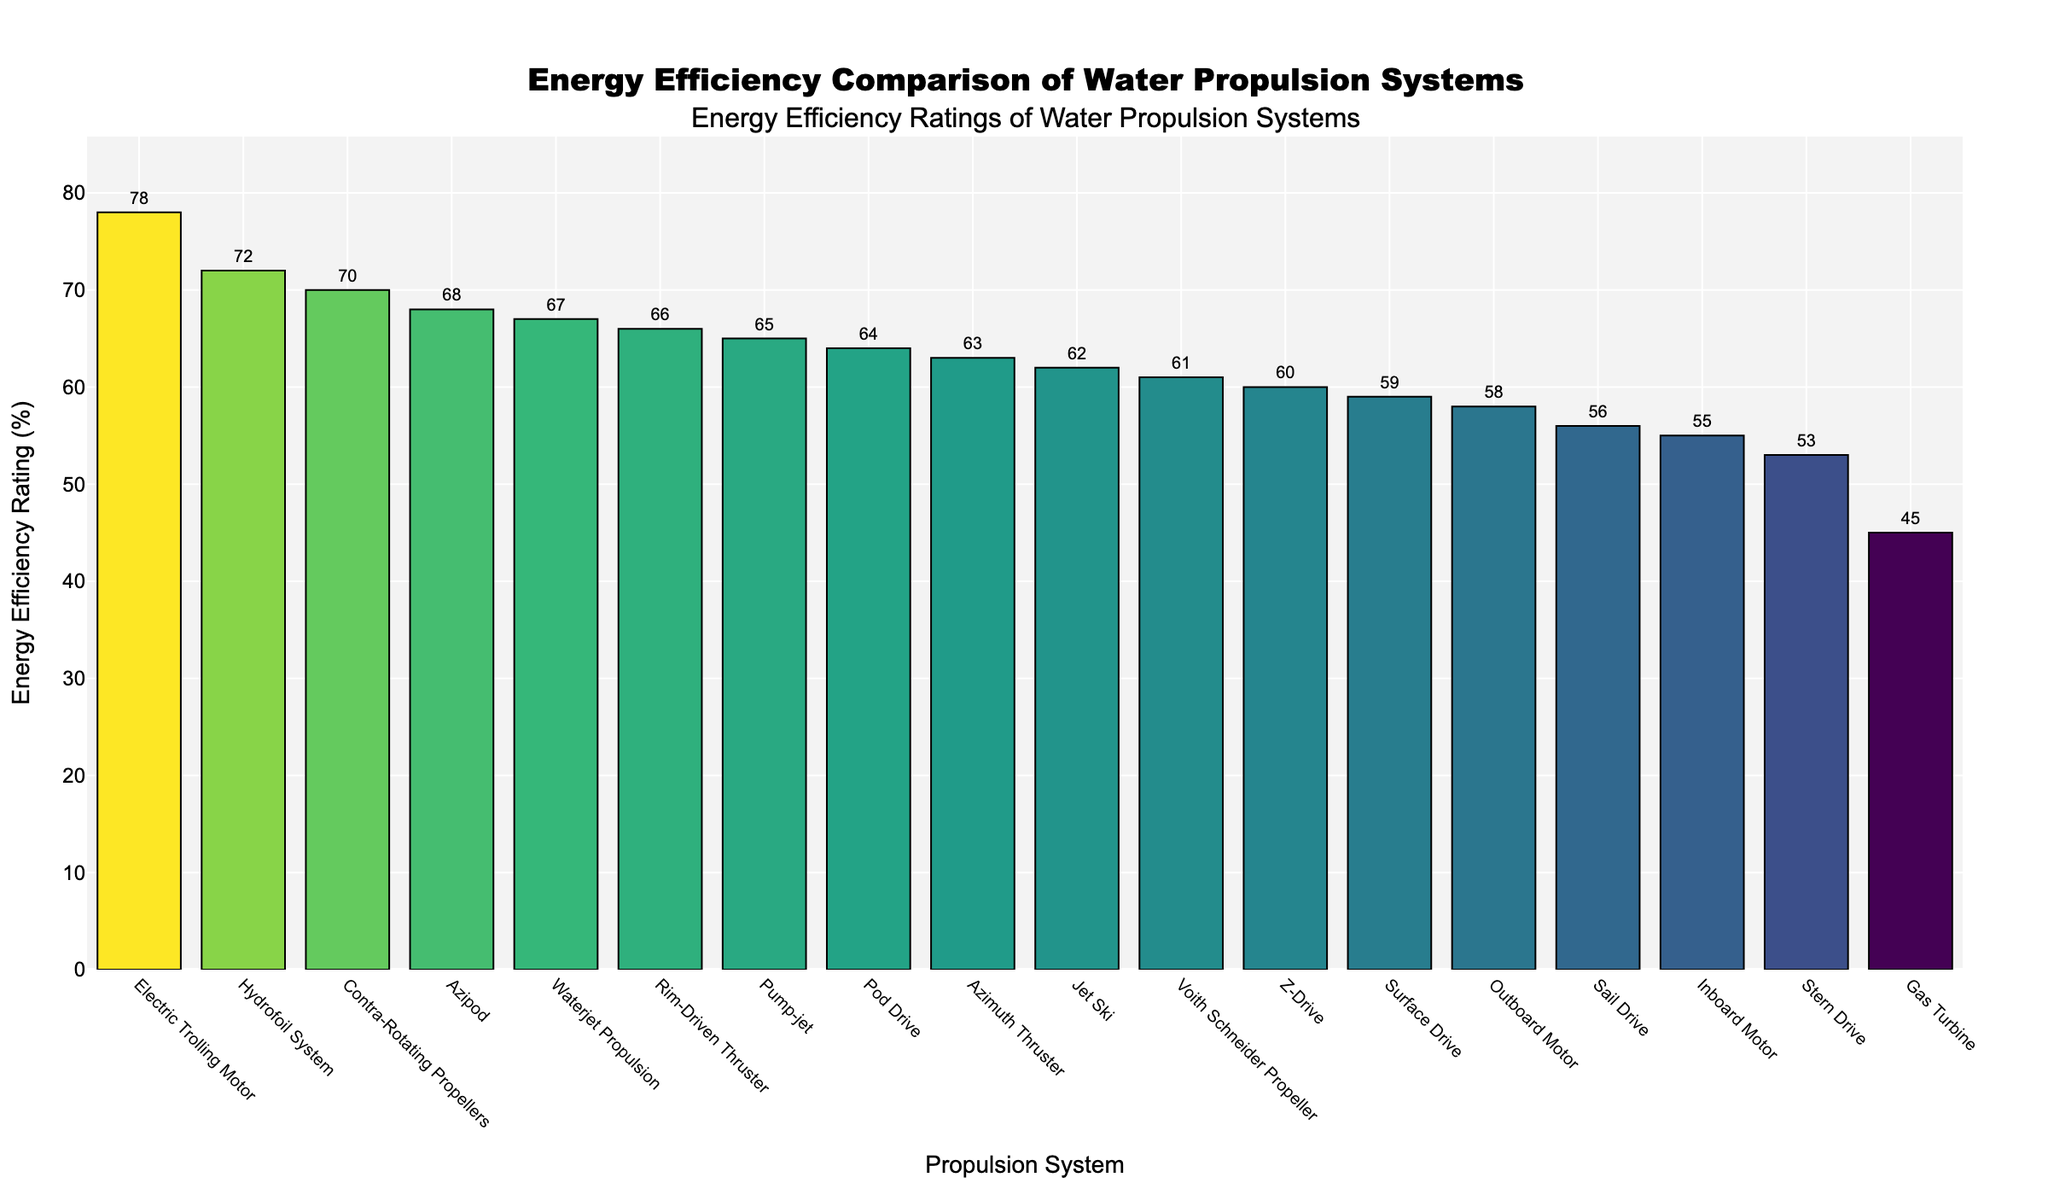What is the most energy-efficient water propulsion system in the chart? By inspecting the lengths of the bars, the Electric Trolling Motor has the highest energy efficiency rating, reaching nearly the top of the y-axis.
Answer: Electric Trolling Motor Which system has the lowest energy efficiency rating? By identifying the shortest bar on the chart, the Gas Turbine has the lowest energy efficiency rating.
Answer: Gas Turbine How many systems have an energy efficiency rating above 60%? Count the bars that extend above the 60% mark on the y-axis. There are 11 systems in this range.
Answer: 11 What is the difference in energy efficiency between the Hydrofoil System and the Pod Drive? The Hydrofoil System is at 72% and the Pod Drive is at 64%. The difference is 72% - 64% = 8%.
Answer: 8% Which systems have a higher energy efficiency rating than the Stern Drive? By comparing the Stern Drive's rating (53%) to others, Jet Ski, Outboard Motor, Pump-jet, Contra-Rotating Propellers, Electric Trolling Motor, and others surpass it.
Answer: Jet Ski, Outboard Motor, Inboard Motor, Pod Drive, Surface Drive, Hydrofoil System, Electric Trolling Motor, Waterjet Propulsion, Pump-jet, Contra-Rotating Propellers, Voith Schneider Propeller, Azimuth Thruster, Z-Drive, Sail Drive, Azipod, Rim-Driven Thruster Which system has an energy efficiency rating closest to the average? Calculate the average energy efficiency rating using the data, then compare each system's rating to find the one closest to that average. The average rating is approximately 62%, and the closest system to this is the Jet Ski with a 62% rating.
Answer: Jet Ski What are the second and third most energy-efficient systems? By examining the figure and noting the descending order, the second and third most efficient systems are the Rim-Driven Thruster (66%) and Azipod (68%) respectively.
Answer: Azipod, Rim-Driven Thruster How does the energy efficiency of the Z-Drive compare to that of the Voith Schneider Propeller? By comparing their values from the chart, the Z-Drive has a 60% rating while the Voith Schneider Propeller is at 61%.
Answer: The Voith Schneider Propeller is 1% more efficient than the Z-Drive If you add up the energy efficiency ratings of Inboard Motor, Stern Drive, and Sail Drive, what is the total? Add the ratings of Inboard Motor (55%), Stern Drive (53%), and Sail Drive (56%). The total is 55% + 53% + 56% = 164%.
Answer: 164% What is the median energy efficiency rating of all the systems? First, list all the efficiency ratings in ascending order, then find the middle value. There are 18 systems, so the median is the average of the 9th and 10th values. The median value is (61% + 62%) / 2 = 61.5%.
Answer: 61.5% 